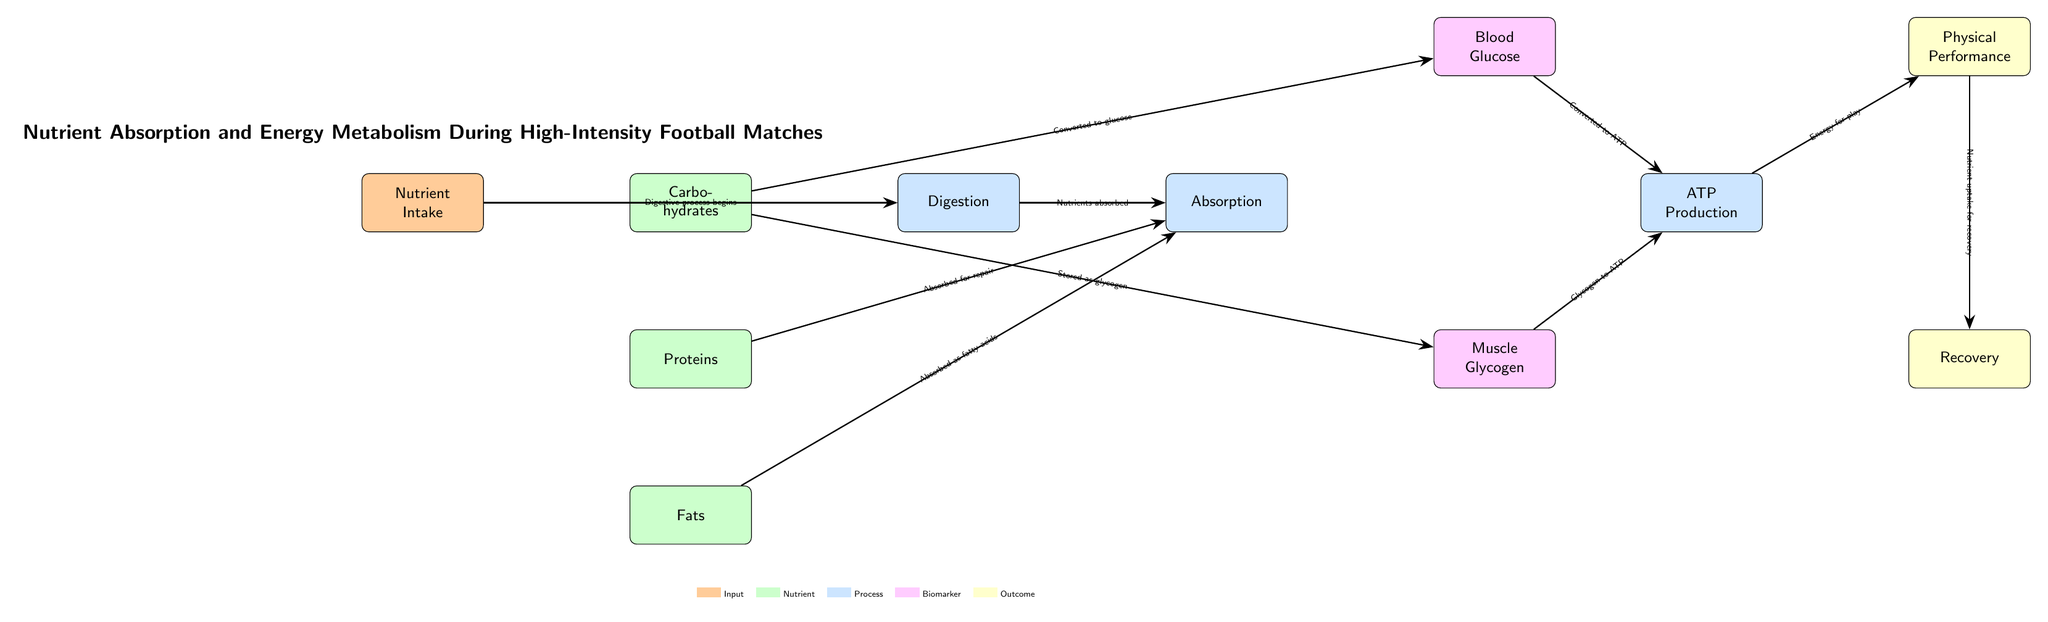What is the first step in the diagram? The first step in the diagram is "Nutrient Intake". It is clearly indicated as the starting point from which the process of digestion begins.
Answer: Nutrient Intake How many nutrient types are shown in the diagram? The diagram shows three types of nutrients: Carbohydrates, Proteins, and Fats. Each nutrient is represented as a separate node below the Nutrient Intake node.
Answer: Three What is the relationship between "Carbohydrates" and "Blood Glucose"? The relationship is that Carbohydrates are "Converted to glucose". This is directly indicated by the arrow connecting these two nodes with the labeling.
Answer: Converted to glucose What happens to "Muscle Glycogen" in the ATP Production process? Muscle Glycogen is "Glycogen to ATP". This indicates that glycogen is utilized to produce ATP, which is essential for energy during high-intensity activities.
Answer: Glycogen to ATP What is the final outcome related to energy in the diagram? The final outcome related to energy is "Physical Performance". This is the last node following the ATP Production node that leads to physical performance during a football match.
Answer: Physical Performance How is energy related to recovery in the diagram? The diagram indicates that "Nutrient uptake for recovery" follows Physical Performance. This illustrates that energy is involved in the recovery process, as nutrients are taken up post-performance.
Answer: Nutrient uptake for recovery 